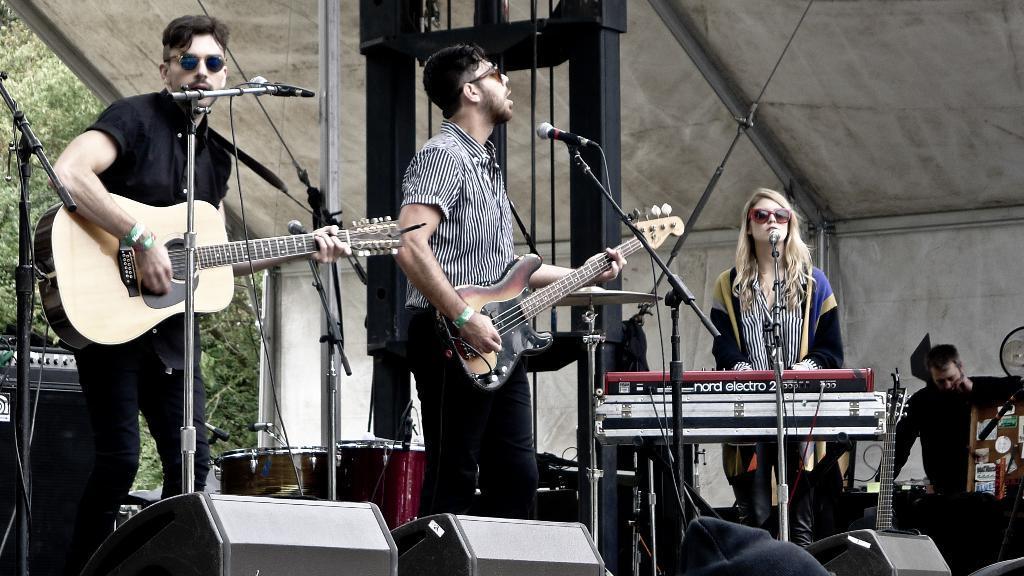In one or two sentences, can you explain what this image depicts? There are people here on the stage playing musical instruments. 